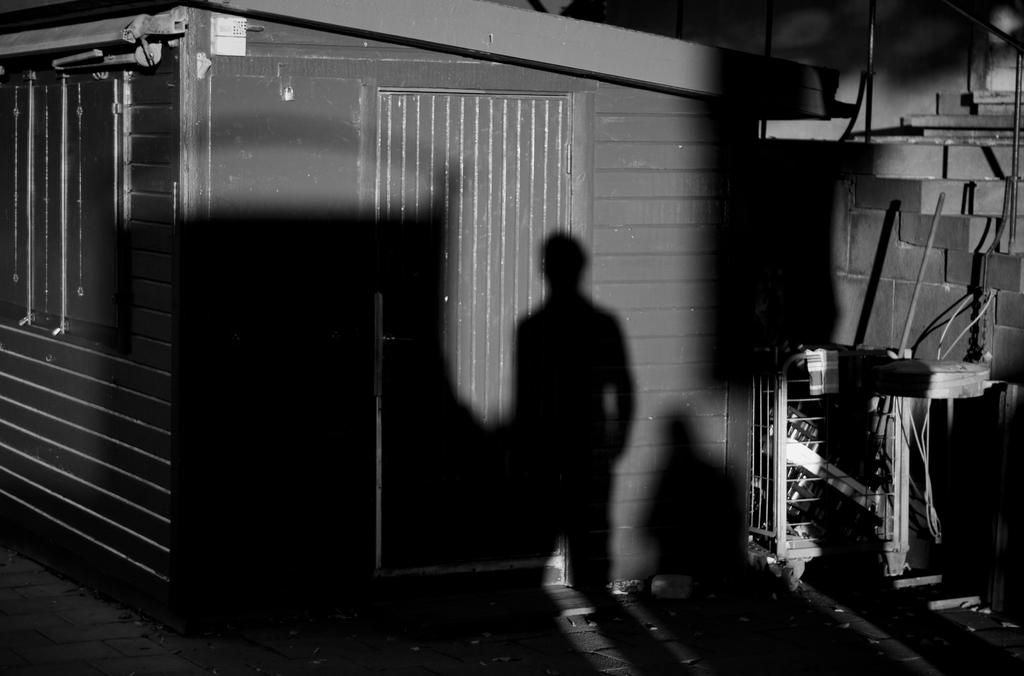What can be seen in the image that resembles a person? There is a shadow of a person in the image. What type of structure is visible in the image? There is a wall in the image. What feature of the wall is present in the image? There is a door in the image. What actor is performing in the image? There is no actor performing in the image; it only shows a shadow of a person, a wall, and a door. What type of light is being used to create the shadow in the image? The facts provided do not mention any specific light source, so we cannot determine the type of light used to create the shadow. 